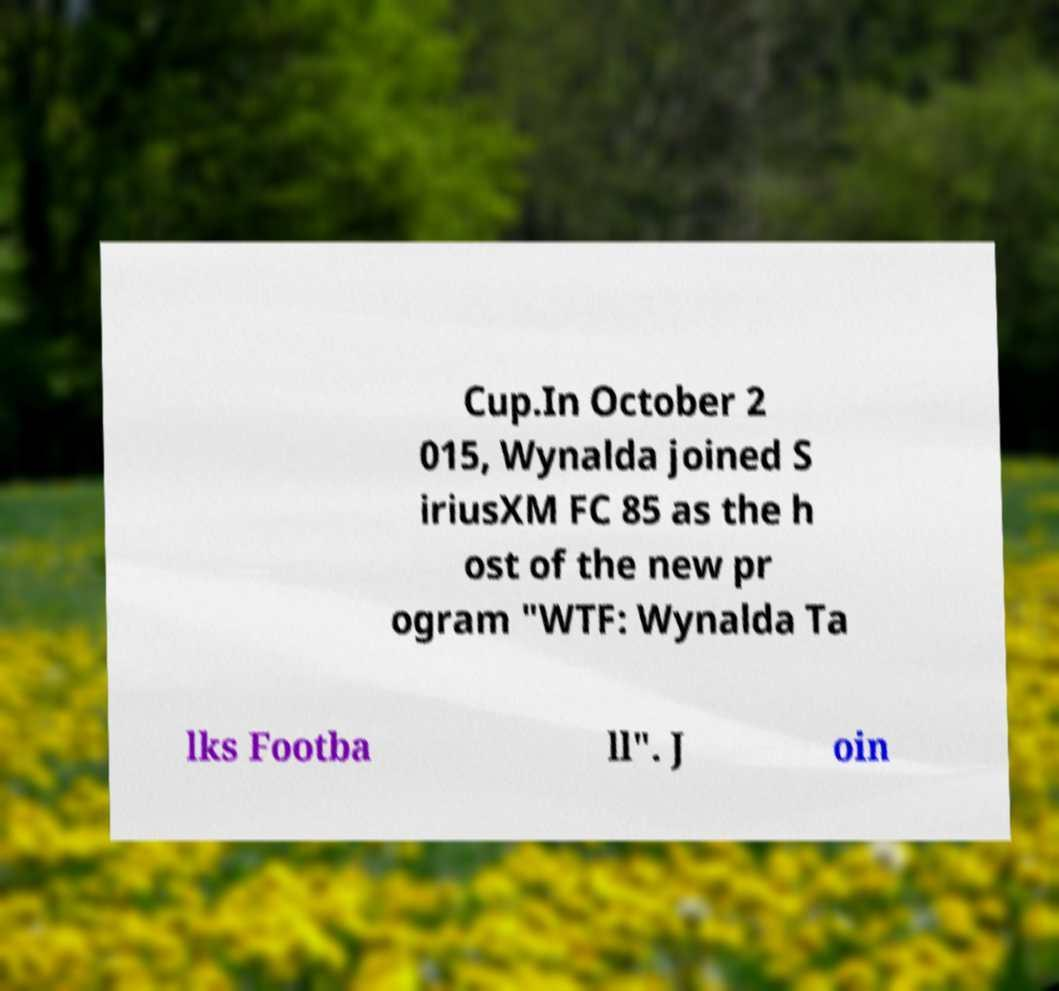I need the written content from this picture converted into text. Can you do that? Cup.In October 2 015, Wynalda joined S iriusXM FC 85 as the h ost of the new pr ogram "WTF: Wynalda Ta lks Footba ll". J oin 